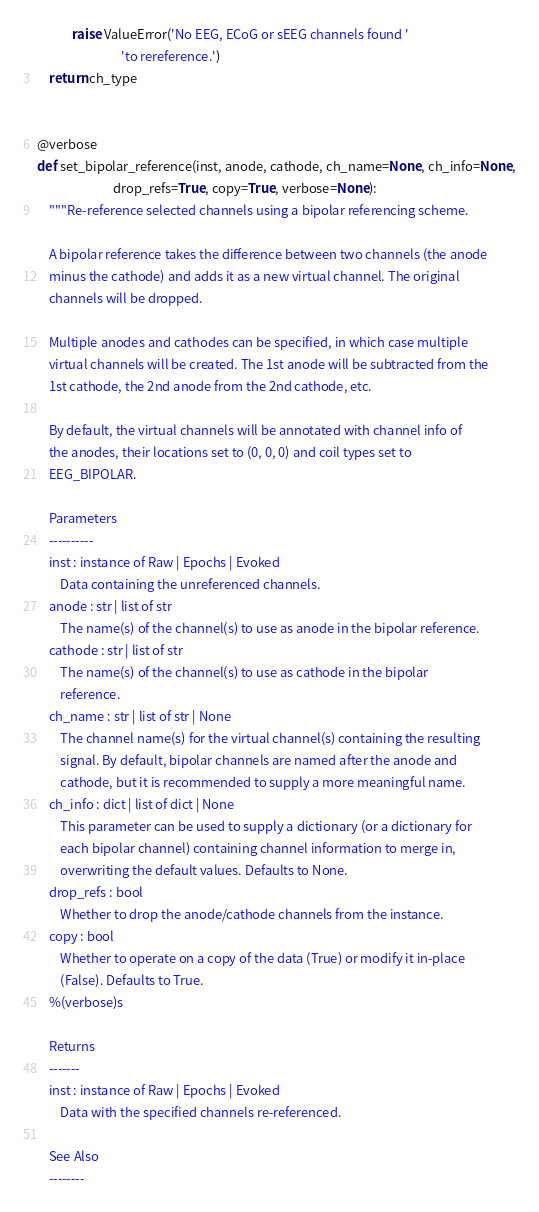Convert code to text. <code><loc_0><loc_0><loc_500><loc_500><_Python_>            raise ValueError('No EEG, ECoG or sEEG channels found '
                             'to rereference.')
    return ch_type


@verbose
def set_bipolar_reference(inst, anode, cathode, ch_name=None, ch_info=None,
                          drop_refs=True, copy=True, verbose=None):
    """Re-reference selected channels using a bipolar referencing scheme.

    A bipolar reference takes the difference between two channels (the anode
    minus the cathode) and adds it as a new virtual channel. The original
    channels will be dropped.

    Multiple anodes and cathodes can be specified, in which case multiple
    virtual channels will be created. The 1st anode will be subtracted from the
    1st cathode, the 2nd anode from the 2nd cathode, etc.

    By default, the virtual channels will be annotated with channel info of
    the anodes, their locations set to (0, 0, 0) and coil types set to
    EEG_BIPOLAR.

    Parameters
    ----------
    inst : instance of Raw | Epochs | Evoked
        Data containing the unreferenced channels.
    anode : str | list of str
        The name(s) of the channel(s) to use as anode in the bipolar reference.
    cathode : str | list of str
        The name(s) of the channel(s) to use as cathode in the bipolar
        reference.
    ch_name : str | list of str | None
        The channel name(s) for the virtual channel(s) containing the resulting
        signal. By default, bipolar channels are named after the anode and
        cathode, but it is recommended to supply a more meaningful name.
    ch_info : dict | list of dict | None
        This parameter can be used to supply a dictionary (or a dictionary for
        each bipolar channel) containing channel information to merge in,
        overwriting the default values. Defaults to None.
    drop_refs : bool
        Whether to drop the anode/cathode channels from the instance.
    copy : bool
        Whether to operate on a copy of the data (True) or modify it in-place
        (False). Defaults to True.
    %(verbose)s

    Returns
    -------
    inst : instance of Raw | Epochs | Evoked
        Data with the specified channels re-referenced.

    See Also
    --------</code> 